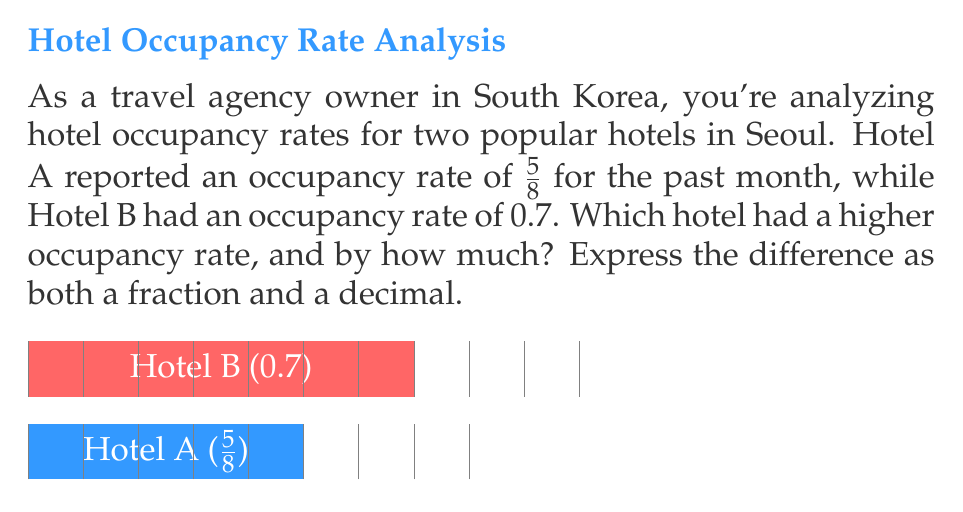Can you solve this math problem? Let's approach this step-by-step:

1) First, we need to convert both occupancy rates to the same format. Let's convert the fraction to a decimal.

   Hotel A: $\frac{5}{8} = 0.625$ (divide 5 by 8)
   Hotel B: 0.7 (already in decimal form)

2) Now we can directly compare:
   0.7 > 0.625

   So, Hotel B had a higher occupancy rate.

3) To find the difference, we subtract:
   $0.7 - 0.625 = 0.075$

4) To express this as a fraction, we need to convert 0.075 to a fraction:
   $0.075 = \frac{75}{1000} = \frac{3}{40}$ (simplified)

Therefore, Hotel B had a higher occupancy rate by $\frac{3}{40}$ or 0.075.
Answer: Hotel B; $\frac{3}{40}$ or 0.075 